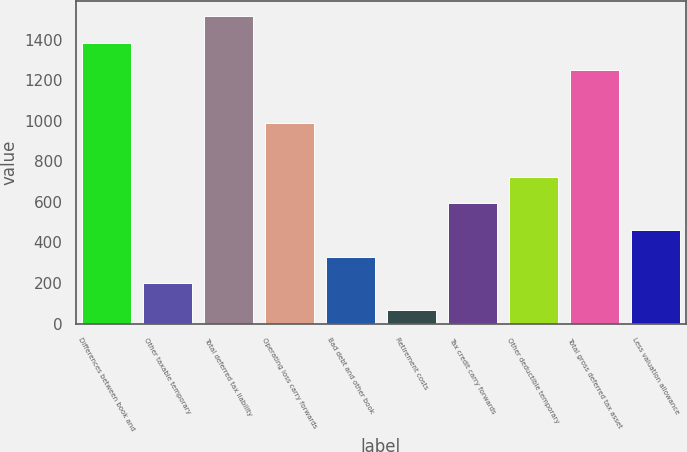<chart> <loc_0><loc_0><loc_500><loc_500><bar_chart><fcel>Differences between book and<fcel>Other taxable temporary<fcel>Total deferred tax liability<fcel>Operating loss carry forwards<fcel>Bad debt and other book<fcel>Retirement costs<fcel>Tax credit carry forwards<fcel>Other deductible temporary<fcel>Total gross deferred tax asset<fcel>Less valuation allowance<nl><fcel>1383<fcel>197.7<fcel>1514.7<fcel>987.9<fcel>329.4<fcel>66<fcel>592.8<fcel>724.5<fcel>1251.3<fcel>461.1<nl></chart> 